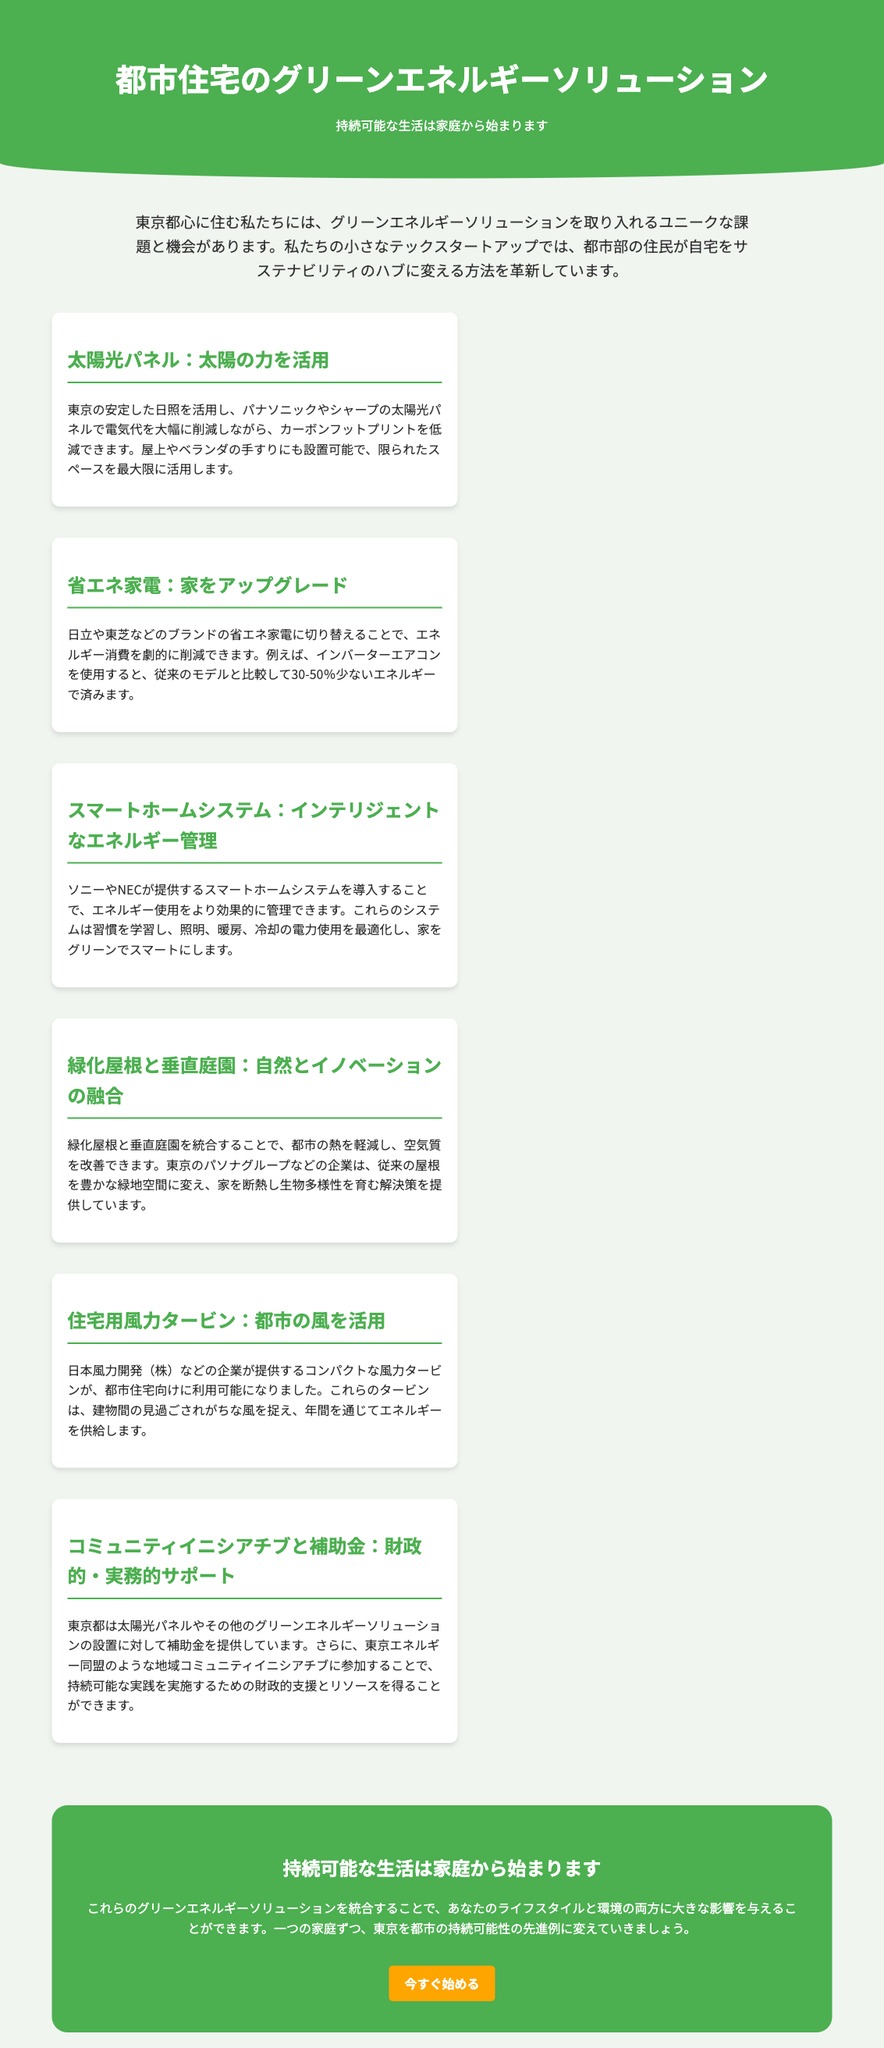What is the title of the advertisement? The title is displayed prominently at the top of the document and states the focus of the content.
Answer: 都市住宅のグリーンエネルギーソリューション What is the main theme of the introduction? The introduction highlights the unique challenges and opportunities for urban residents regarding green energy solutions.
Answer: 持続可能な生活は家庭から始まります Which company offers solar panel solutions? The document mentions specific companies that provide solar panel technology, highlighting their availability and benefits.
Answer: パナソニックやシャープ How much less energy do inverter air conditioners use compared to conventional models? The advertisement provides a specific percentage range for energy savings from using inverter technology.
Answer: 30-50% What is one benefit of smart home systems mentioned in the document? The document lists the advantages of using smart home systems for managing energy effectively within households.
Answer: インテリジェントなエネルギー管理 What type of garden solution is mentioned to improve air quality? The document describes a solution that integrates nature within urban settings to enhance environmental conditions.
Answer: 緑化屋根と垂直庭園 What financial support does Tokyo offer for green energy installations? The advertisement specifies that financial assistance is available for adopting certain energy solutions, reflecting city-level initiatives.
Answer: 補助金 How does the advertisement suggest urban residents can transform their homes? It emphasizes that by incorporating suggested solutions, residents can positively impact their lifestyle and the environment.
Answer: サステナビリティのハブ What is the recommended call to action at the end of the document? At the conclusion, there is a clear call to action encouraging readers to engage with the solutions presented.
Answer: 今すぐ始める 